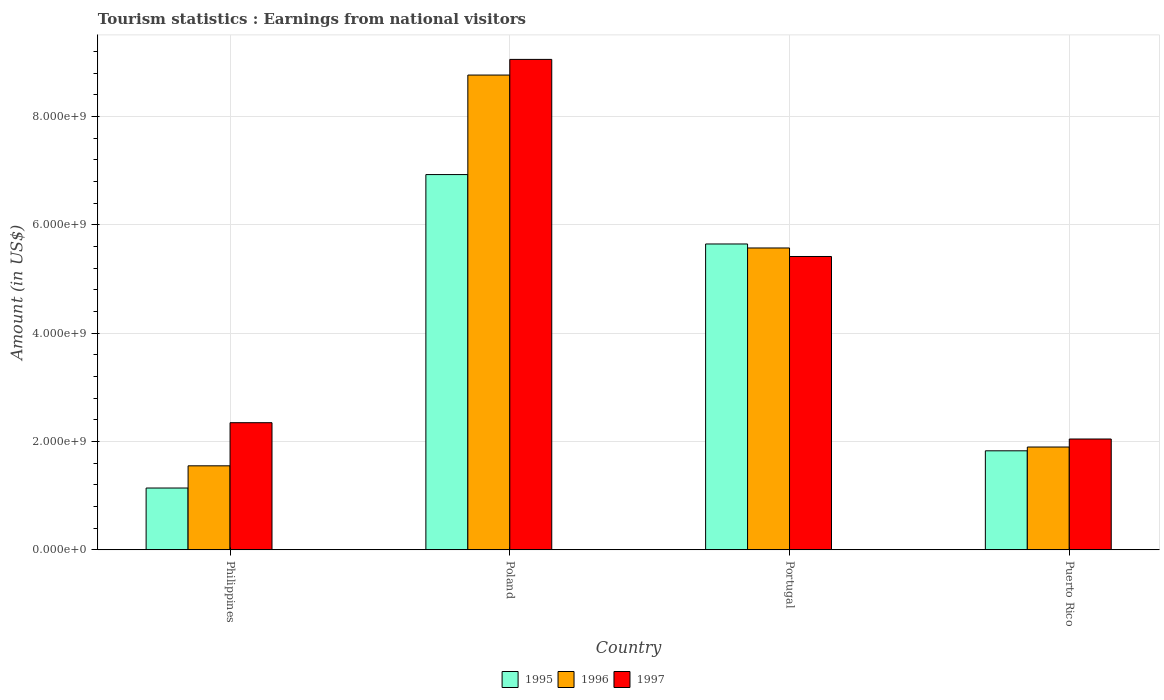How many different coloured bars are there?
Your answer should be compact. 3. How many bars are there on the 2nd tick from the left?
Ensure brevity in your answer.  3. How many bars are there on the 4th tick from the right?
Give a very brief answer. 3. In how many cases, is the number of bars for a given country not equal to the number of legend labels?
Offer a terse response. 0. What is the earnings from national visitors in 1997 in Poland?
Provide a short and direct response. 9.05e+09. Across all countries, what is the maximum earnings from national visitors in 1997?
Make the answer very short. 9.05e+09. Across all countries, what is the minimum earnings from national visitors in 1995?
Provide a short and direct response. 1.14e+09. In which country was the earnings from national visitors in 1997 maximum?
Keep it short and to the point. Poland. In which country was the earnings from national visitors in 1997 minimum?
Provide a short and direct response. Puerto Rico. What is the total earnings from national visitors in 1997 in the graph?
Your response must be concise. 1.89e+1. What is the difference between the earnings from national visitors in 1996 in Philippines and that in Puerto Rico?
Keep it short and to the point. -3.47e+08. What is the difference between the earnings from national visitors in 1997 in Philippines and the earnings from national visitors in 1995 in Poland?
Offer a very short reply. -4.58e+09. What is the average earnings from national visitors in 1997 per country?
Offer a very short reply. 4.72e+09. What is the difference between the earnings from national visitors of/in 1997 and earnings from national visitors of/in 1996 in Portugal?
Provide a succinct answer. -1.57e+08. What is the ratio of the earnings from national visitors in 1996 in Philippines to that in Puerto Rico?
Ensure brevity in your answer.  0.82. Is the earnings from national visitors in 1995 in Poland less than that in Puerto Rico?
Your answer should be very brief. No. Is the difference between the earnings from national visitors in 1997 in Philippines and Poland greater than the difference between the earnings from national visitors in 1996 in Philippines and Poland?
Provide a short and direct response. Yes. What is the difference between the highest and the second highest earnings from national visitors in 1997?
Provide a succinct answer. 6.71e+09. What is the difference between the highest and the lowest earnings from national visitors in 1996?
Ensure brevity in your answer.  7.21e+09. Is the sum of the earnings from national visitors in 1997 in Philippines and Puerto Rico greater than the maximum earnings from national visitors in 1995 across all countries?
Make the answer very short. No. What does the 2nd bar from the left in Puerto Rico represents?
Offer a terse response. 1996. Is it the case that in every country, the sum of the earnings from national visitors in 1995 and earnings from national visitors in 1997 is greater than the earnings from national visitors in 1996?
Give a very brief answer. Yes. How many bars are there?
Offer a very short reply. 12. What is the difference between two consecutive major ticks on the Y-axis?
Offer a very short reply. 2.00e+09. How many legend labels are there?
Your answer should be very brief. 3. What is the title of the graph?
Offer a very short reply. Tourism statistics : Earnings from national visitors. What is the Amount (in US$) in 1995 in Philippines?
Ensure brevity in your answer.  1.14e+09. What is the Amount (in US$) in 1996 in Philippines?
Keep it short and to the point. 1.55e+09. What is the Amount (in US$) of 1997 in Philippines?
Ensure brevity in your answer.  2.35e+09. What is the Amount (in US$) in 1995 in Poland?
Your response must be concise. 6.93e+09. What is the Amount (in US$) of 1996 in Poland?
Your response must be concise. 8.76e+09. What is the Amount (in US$) of 1997 in Poland?
Keep it short and to the point. 9.05e+09. What is the Amount (in US$) of 1995 in Portugal?
Your answer should be compact. 5.65e+09. What is the Amount (in US$) in 1996 in Portugal?
Make the answer very short. 5.57e+09. What is the Amount (in US$) of 1997 in Portugal?
Your response must be concise. 5.42e+09. What is the Amount (in US$) in 1995 in Puerto Rico?
Your response must be concise. 1.83e+09. What is the Amount (in US$) in 1996 in Puerto Rico?
Make the answer very short. 1.90e+09. What is the Amount (in US$) of 1997 in Puerto Rico?
Your answer should be compact. 2.05e+09. Across all countries, what is the maximum Amount (in US$) of 1995?
Keep it short and to the point. 6.93e+09. Across all countries, what is the maximum Amount (in US$) of 1996?
Keep it short and to the point. 8.76e+09. Across all countries, what is the maximum Amount (in US$) in 1997?
Make the answer very short. 9.05e+09. Across all countries, what is the minimum Amount (in US$) in 1995?
Provide a succinct answer. 1.14e+09. Across all countries, what is the minimum Amount (in US$) in 1996?
Provide a succinct answer. 1.55e+09. Across all countries, what is the minimum Amount (in US$) in 1997?
Offer a very short reply. 2.05e+09. What is the total Amount (in US$) of 1995 in the graph?
Provide a succinct answer. 1.55e+1. What is the total Amount (in US$) in 1996 in the graph?
Make the answer very short. 1.78e+1. What is the total Amount (in US$) in 1997 in the graph?
Provide a succinct answer. 1.89e+1. What is the difference between the Amount (in US$) in 1995 in Philippines and that in Poland?
Make the answer very short. -5.79e+09. What is the difference between the Amount (in US$) of 1996 in Philippines and that in Poland?
Make the answer very short. -7.21e+09. What is the difference between the Amount (in US$) in 1997 in Philippines and that in Poland?
Make the answer very short. -6.71e+09. What is the difference between the Amount (in US$) of 1995 in Philippines and that in Portugal?
Ensure brevity in your answer.  -4.50e+09. What is the difference between the Amount (in US$) of 1996 in Philippines and that in Portugal?
Provide a succinct answer. -4.02e+09. What is the difference between the Amount (in US$) of 1997 in Philippines and that in Portugal?
Your answer should be compact. -3.07e+09. What is the difference between the Amount (in US$) of 1995 in Philippines and that in Puerto Rico?
Offer a very short reply. -6.87e+08. What is the difference between the Amount (in US$) in 1996 in Philippines and that in Puerto Rico?
Offer a terse response. -3.47e+08. What is the difference between the Amount (in US$) of 1997 in Philippines and that in Puerto Rico?
Offer a terse response. 3.01e+08. What is the difference between the Amount (in US$) of 1995 in Poland and that in Portugal?
Ensure brevity in your answer.  1.28e+09. What is the difference between the Amount (in US$) of 1996 in Poland and that in Portugal?
Keep it short and to the point. 3.19e+09. What is the difference between the Amount (in US$) of 1997 in Poland and that in Portugal?
Ensure brevity in your answer.  3.64e+09. What is the difference between the Amount (in US$) in 1995 in Poland and that in Puerto Rico?
Make the answer very short. 5.10e+09. What is the difference between the Amount (in US$) of 1996 in Poland and that in Puerto Rico?
Provide a short and direct response. 6.87e+09. What is the difference between the Amount (in US$) in 1997 in Poland and that in Puerto Rico?
Offer a very short reply. 7.01e+09. What is the difference between the Amount (in US$) of 1995 in Portugal and that in Puerto Rico?
Provide a short and direct response. 3.82e+09. What is the difference between the Amount (in US$) in 1996 in Portugal and that in Puerto Rico?
Keep it short and to the point. 3.67e+09. What is the difference between the Amount (in US$) in 1997 in Portugal and that in Puerto Rico?
Your answer should be compact. 3.37e+09. What is the difference between the Amount (in US$) of 1995 in Philippines and the Amount (in US$) of 1996 in Poland?
Your response must be concise. -7.62e+09. What is the difference between the Amount (in US$) of 1995 in Philippines and the Amount (in US$) of 1997 in Poland?
Make the answer very short. -7.91e+09. What is the difference between the Amount (in US$) of 1996 in Philippines and the Amount (in US$) of 1997 in Poland?
Offer a terse response. -7.50e+09. What is the difference between the Amount (in US$) of 1995 in Philippines and the Amount (in US$) of 1996 in Portugal?
Offer a very short reply. -4.43e+09. What is the difference between the Amount (in US$) in 1995 in Philippines and the Amount (in US$) in 1997 in Portugal?
Offer a very short reply. -4.27e+09. What is the difference between the Amount (in US$) in 1996 in Philippines and the Amount (in US$) in 1997 in Portugal?
Your answer should be compact. -3.86e+09. What is the difference between the Amount (in US$) in 1995 in Philippines and the Amount (in US$) in 1996 in Puerto Rico?
Make the answer very short. -7.57e+08. What is the difference between the Amount (in US$) of 1995 in Philippines and the Amount (in US$) of 1997 in Puerto Rico?
Give a very brief answer. -9.05e+08. What is the difference between the Amount (in US$) of 1996 in Philippines and the Amount (in US$) of 1997 in Puerto Rico?
Your answer should be compact. -4.95e+08. What is the difference between the Amount (in US$) of 1995 in Poland and the Amount (in US$) of 1996 in Portugal?
Keep it short and to the point. 1.36e+09. What is the difference between the Amount (in US$) in 1995 in Poland and the Amount (in US$) in 1997 in Portugal?
Provide a succinct answer. 1.51e+09. What is the difference between the Amount (in US$) in 1996 in Poland and the Amount (in US$) in 1997 in Portugal?
Your answer should be compact. 3.35e+09. What is the difference between the Amount (in US$) in 1995 in Poland and the Amount (in US$) in 1996 in Puerto Rico?
Offer a very short reply. 5.03e+09. What is the difference between the Amount (in US$) of 1995 in Poland and the Amount (in US$) of 1997 in Puerto Rico?
Offer a terse response. 4.88e+09. What is the difference between the Amount (in US$) of 1996 in Poland and the Amount (in US$) of 1997 in Puerto Rico?
Provide a succinct answer. 6.72e+09. What is the difference between the Amount (in US$) of 1995 in Portugal and the Amount (in US$) of 1996 in Puerto Rico?
Offer a terse response. 3.75e+09. What is the difference between the Amount (in US$) of 1995 in Portugal and the Amount (in US$) of 1997 in Puerto Rico?
Offer a terse response. 3.60e+09. What is the difference between the Amount (in US$) in 1996 in Portugal and the Amount (in US$) in 1997 in Puerto Rico?
Provide a succinct answer. 3.53e+09. What is the average Amount (in US$) in 1995 per country?
Your response must be concise. 3.89e+09. What is the average Amount (in US$) in 1996 per country?
Your answer should be very brief. 4.45e+09. What is the average Amount (in US$) of 1997 per country?
Your answer should be very brief. 4.72e+09. What is the difference between the Amount (in US$) in 1995 and Amount (in US$) in 1996 in Philippines?
Make the answer very short. -4.10e+08. What is the difference between the Amount (in US$) in 1995 and Amount (in US$) in 1997 in Philippines?
Provide a succinct answer. -1.21e+09. What is the difference between the Amount (in US$) of 1996 and Amount (in US$) of 1997 in Philippines?
Keep it short and to the point. -7.96e+08. What is the difference between the Amount (in US$) of 1995 and Amount (in US$) of 1996 in Poland?
Your answer should be very brief. -1.84e+09. What is the difference between the Amount (in US$) in 1995 and Amount (in US$) in 1997 in Poland?
Ensure brevity in your answer.  -2.13e+09. What is the difference between the Amount (in US$) of 1996 and Amount (in US$) of 1997 in Poland?
Provide a short and direct response. -2.89e+08. What is the difference between the Amount (in US$) in 1995 and Amount (in US$) in 1996 in Portugal?
Ensure brevity in your answer.  7.40e+07. What is the difference between the Amount (in US$) in 1995 and Amount (in US$) in 1997 in Portugal?
Your response must be concise. 2.31e+08. What is the difference between the Amount (in US$) in 1996 and Amount (in US$) in 1997 in Portugal?
Your answer should be very brief. 1.57e+08. What is the difference between the Amount (in US$) in 1995 and Amount (in US$) in 1996 in Puerto Rico?
Keep it short and to the point. -7.00e+07. What is the difference between the Amount (in US$) of 1995 and Amount (in US$) of 1997 in Puerto Rico?
Provide a short and direct response. -2.18e+08. What is the difference between the Amount (in US$) in 1996 and Amount (in US$) in 1997 in Puerto Rico?
Your answer should be compact. -1.48e+08. What is the ratio of the Amount (in US$) in 1995 in Philippines to that in Poland?
Provide a short and direct response. 0.16. What is the ratio of the Amount (in US$) in 1996 in Philippines to that in Poland?
Provide a short and direct response. 0.18. What is the ratio of the Amount (in US$) in 1997 in Philippines to that in Poland?
Keep it short and to the point. 0.26. What is the ratio of the Amount (in US$) of 1995 in Philippines to that in Portugal?
Provide a short and direct response. 0.2. What is the ratio of the Amount (in US$) of 1996 in Philippines to that in Portugal?
Your response must be concise. 0.28. What is the ratio of the Amount (in US$) in 1997 in Philippines to that in Portugal?
Provide a short and direct response. 0.43. What is the ratio of the Amount (in US$) in 1995 in Philippines to that in Puerto Rico?
Your response must be concise. 0.62. What is the ratio of the Amount (in US$) in 1996 in Philippines to that in Puerto Rico?
Keep it short and to the point. 0.82. What is the ratio of the Amount (in US$) of 1997 in Philippines to that in Puerto Rico?
Provide a succinct answer. 1.15. What is the ratio of the Amount (in US$) in 1995 in Poland to that in Portugal?
Keep it short and to the point. 1.23. What is the ratio of the Amount (in US$) of 1996 in Poland to that in Portugal?
Offer a very short reply. 1.57. What is the ratio of the Amount (in US$) in 1997 in Poland to that in Portugal?
Your response must be concise. 1.67. What is the ratio of the Amount (in US$) of 1995 in Poland to that in Puerto Rico?
Provide a short and direct response. 3.79. What is the ratio of the Amount (in US$) in 1996 in Poland to that in Puerto Rico?
Give a very brief answer. 4.62. What is the ratio of the Amount (in US$) in 1997 in Poland to that in Puerto Rico?
Your response must be concise. 4.42. What is the ratio of the Amount (in US$) of 1995 in Portugal to that in Puerto Rico?
Your answer should be compact. 3.09. What is the ratio of the Amount (in US$) of 1996 in Portugal to that in Puerto Rico?
Provide a succinct answer. 2.94. What is the ratio of the Amount (in US$) of 1997 in Portugal to that in Puerto Rico?
Your answer should be compact. 2.65. What is the difference between the highest and the second highest Amount (in US$) in 1995?
Offer a very short reply. 1.28e+09. What is the difference between the highest and the second highest Amount (in US$) of 1996?
Provide a short and direct response. 3.19e+09. What is the difference between the highest and the second highest Amount (in US$) in 1997?
Offer a very short reply. 3.64e+09. What is the difference between the highest and the lowest Amount (in US$) in 1995?
Your answer should be compact. 5.79e+09. What is the difference between the highest and the lowest Amount (in US$) of 1996?
Your response must be concise. 7.21e+09. What is the difference between the highest and the lowest Amount (in US$) in 1997?
Provide a short and direct response. 7.01e+09. 